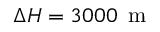<formula> <loc_0><loc_0><loc_500><loc_500>\Delta H = 3 0 0 0 \, m</formula> 